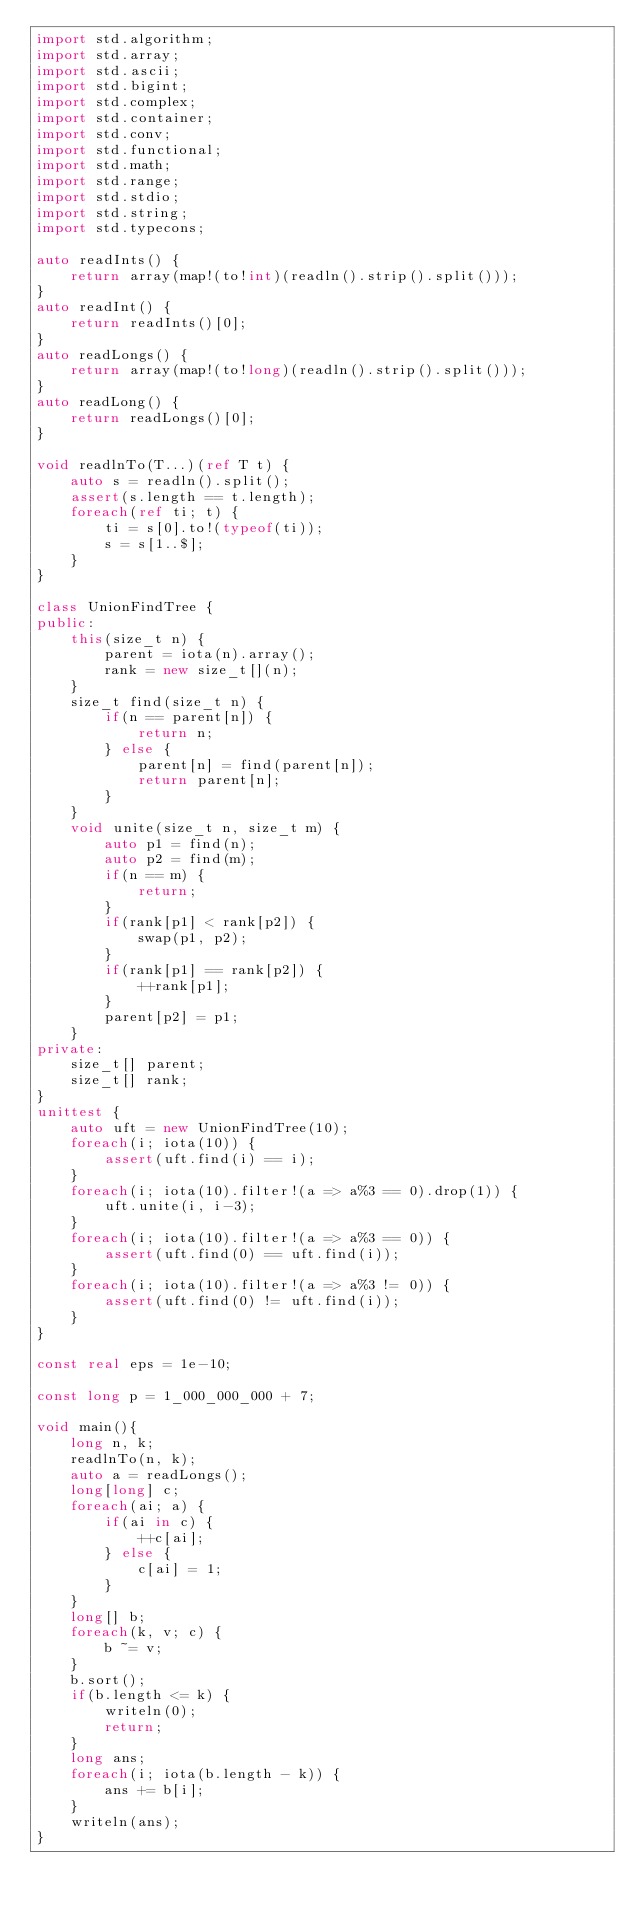<code> <loc_0><loc_0><loc_500><loc_500><_D_>import std.algorithm;
import std.array;
import std.ascii;
import std.bigint;
import std.complex;
import std.container;
import std.conv;
import std.functional;
import std.math;
import std.range;
import std.stdio;
import std.string;
import std.typecons;

auto readInts() {
	return array(map!(to!int)(readln().strip().split()));
}
auto readInt() {
	return readInts()[0];
}
auto readLongs() {
	return array(map!(to!long)(readln().strip().split()));
}
auto readLong() {
	return readLongs()[0];
}

void readlnTo(T...)(ref T t) {
    auto s = readln().split();
    assert(s.length == t.length);
    foreach(ref ti; t) {
        ti = s[0].to!(typeof(ti));
        s = s[1..$];
    }
}

class UnionFindTree {
public:
    this(size_t n) {
        parent = iota(n).array();
        rank = new size_t[](n);
    }
    size_t find(size_t n) {
        if(n == parent[n]) {
            return n;
        } else {
            parent[n] = find(parent[n]);
            return parent[n];
        }
    }
    void unite(size_t n, size_t m) {
        auto p1 = find(n);
        auto p2 = find(m);
        if(n == m) {
            return;
        }
        if(rank[p1] < rank[p2]) {
            swap(p1, p2);
        }
        if(rank[p1] == rank[p2]) {
            ++rank[p1];
        }
        parent[p2] = p1;
    }
private:
    size_t[] parent;
    size_t[] rank;
}
unittest {
    auto uft = new UnionFindTree(10);
    foreach(i; iota(10)) {
        assert(uft.find(i) == i);
    }
    foreach(i; iota(10).filter!(a => a%3 == 0).drop(1)) {
        uft.unite(i, i-3);
    }
    foreach(i; iota(10).filter!(a => a%3 == 0)) {
        assert(uft.find(0) == uft.find(i));
    }
    foreach(i; iota(10).filter!(a => a%3 != 0)) {
        assert(uft.find(0) != uft.find(i));
    }
}

const real eps = 1e-10;

const long p = 1_000_000_000 + 7;

void main(){
    long n, k;
    readlnTo(n, k);
    auto a = readLongs();
    long[long] c;
    foreach(ai; a) {
        if(ai in c) {
            ++c[ai];
        } else {
            c[ai] = 1;
        }
    }
    long[] b;
    foreach(k, v; c) {
        b ~= v;
    }
    b.sort();
    if(b.length <= k) {
        writeln(0);
        return;
    }
    long ans;
    foreach(i; iota(b.length - k)) { 
        ans += b[i];
    }
    writeln(ans);
}

</code> 